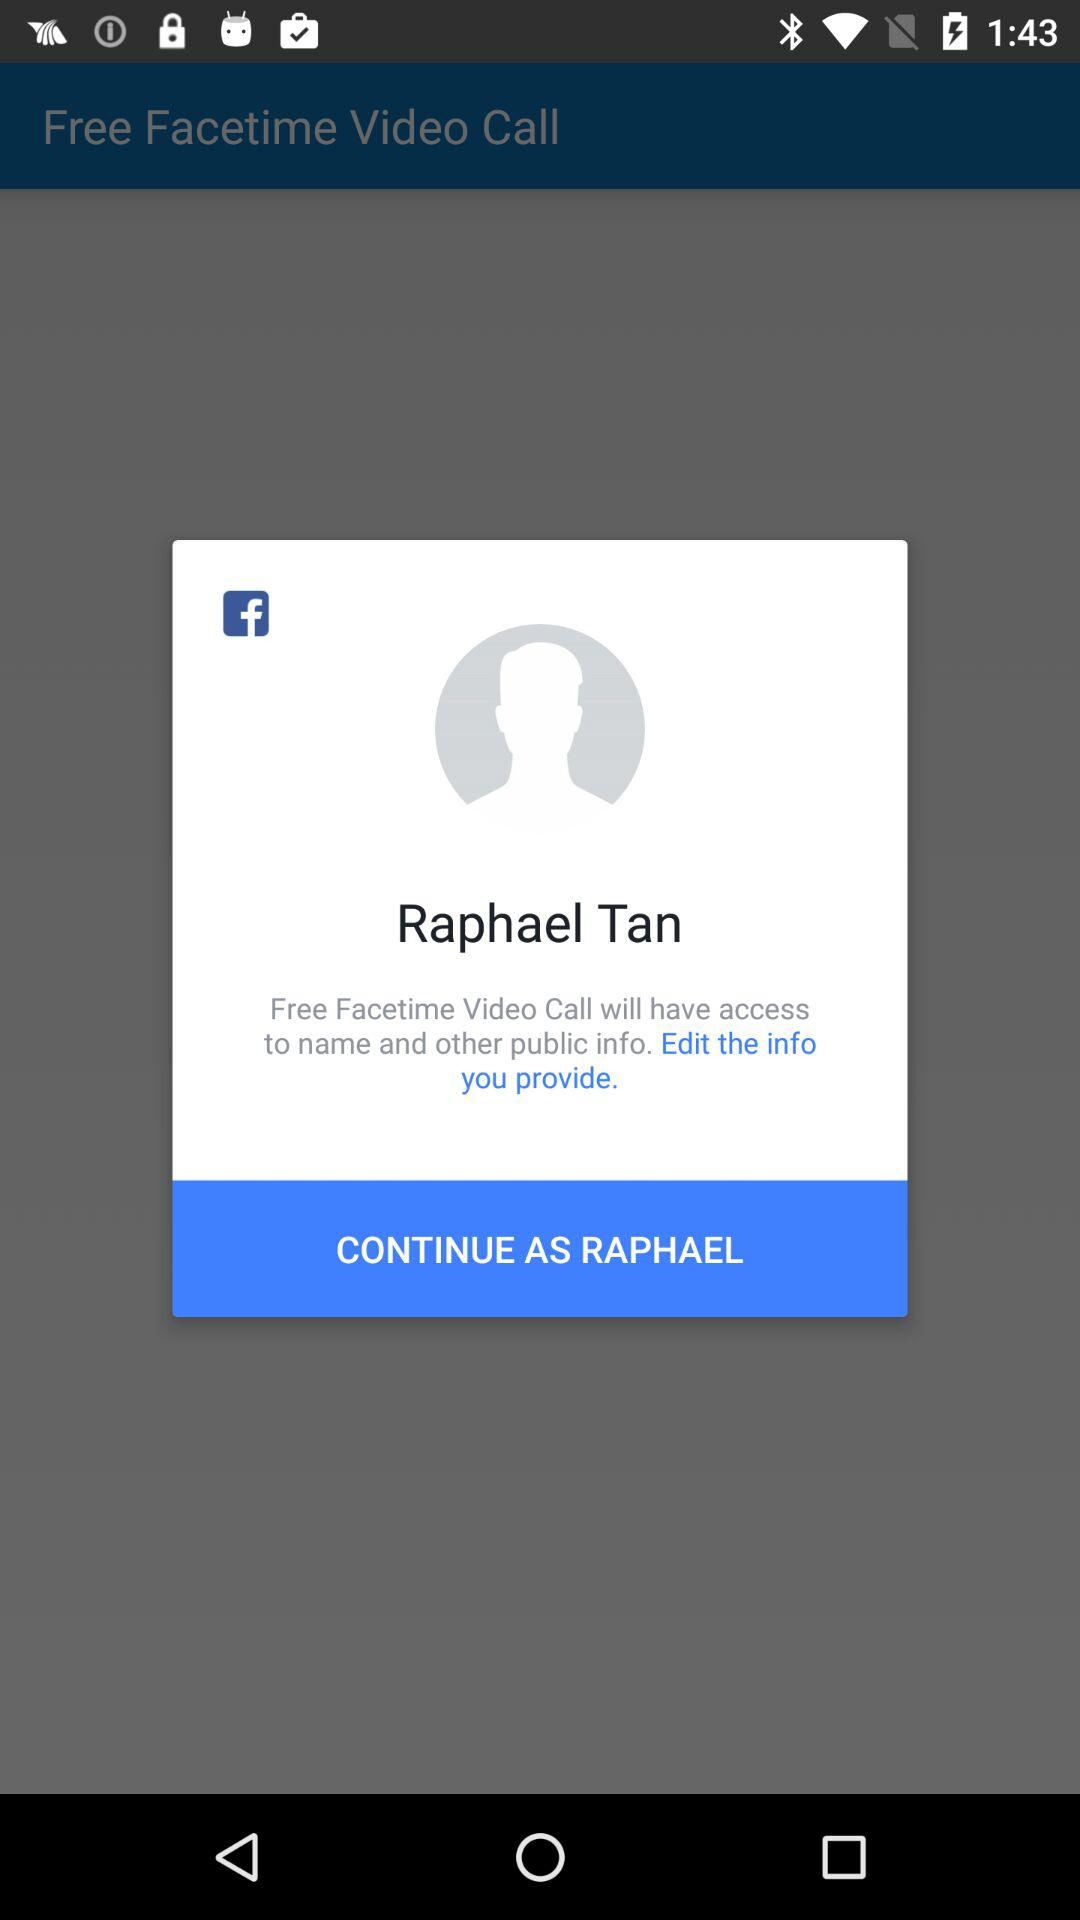What is the login name? The login name is Raphael Tan. 